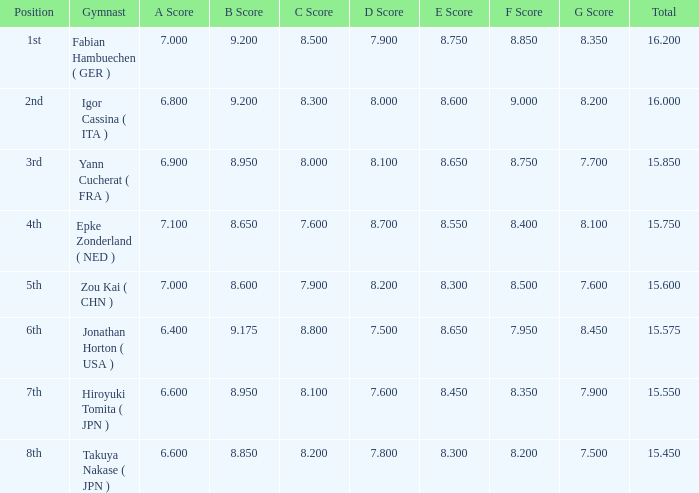What was the total rating that had a score higher than 7 and a b score smaller than 8.65? None. 